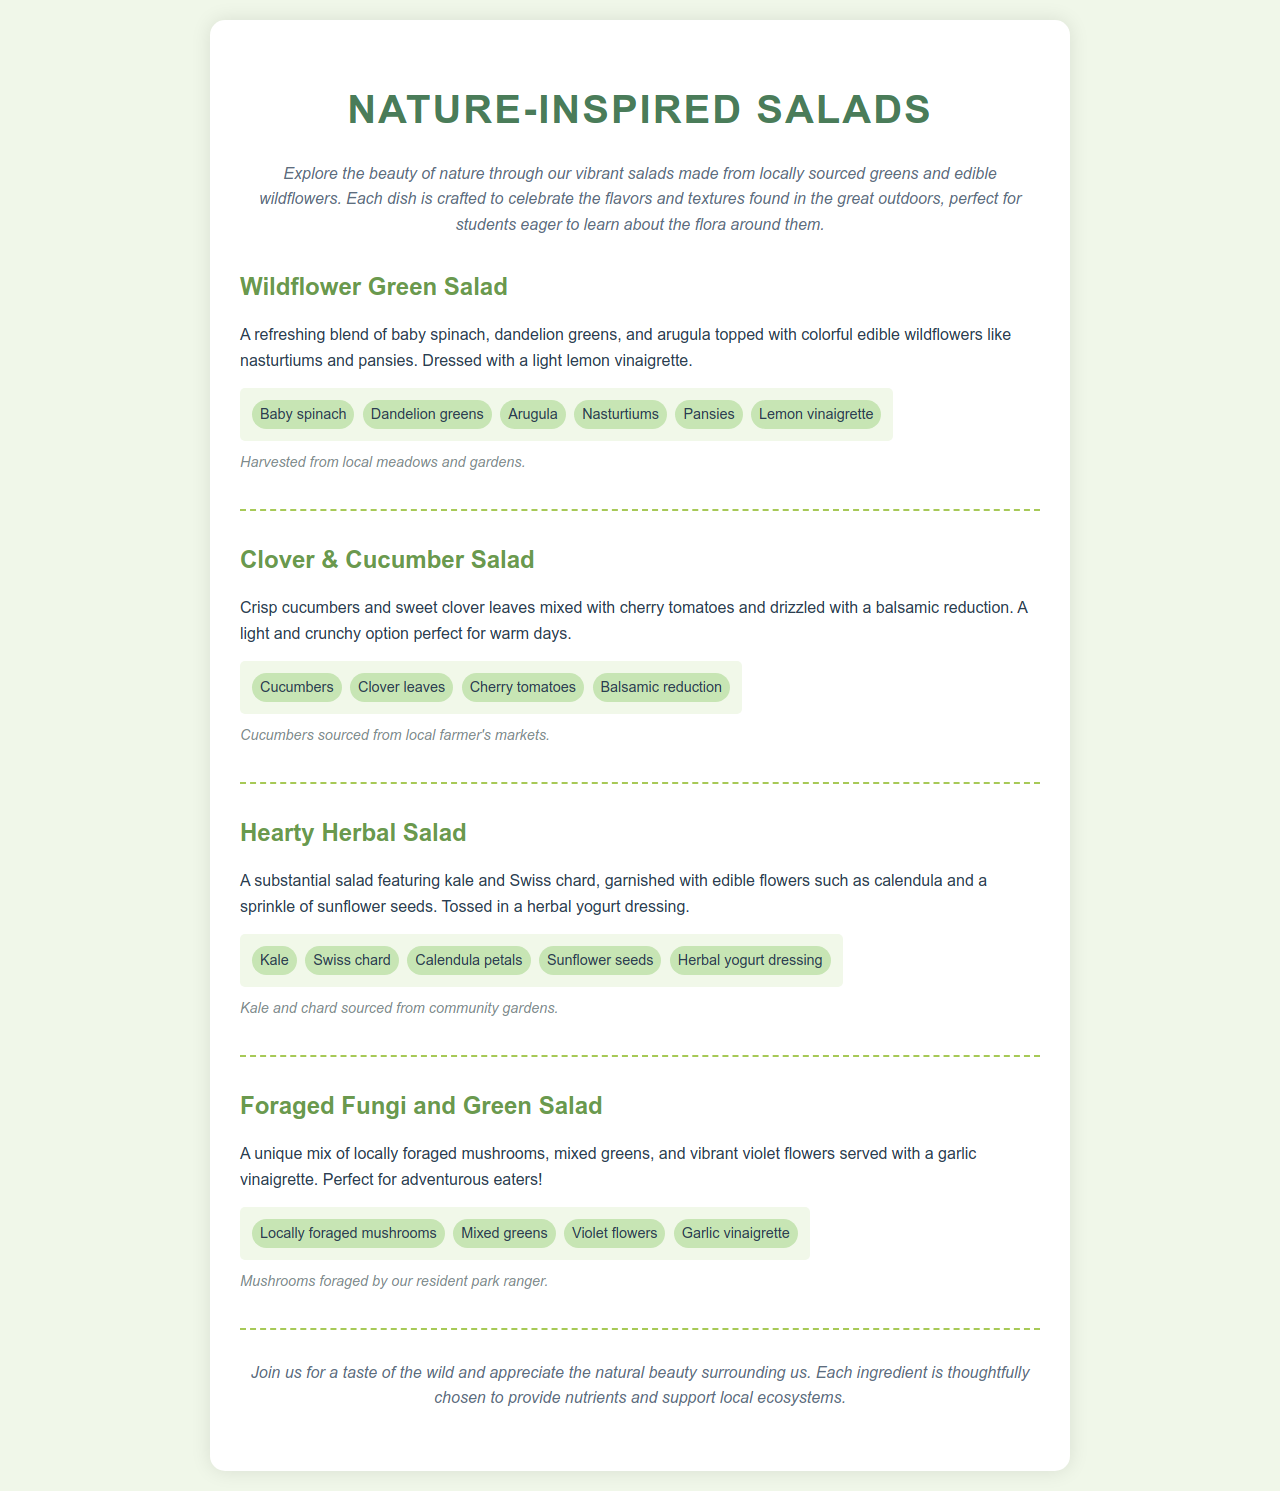What is the name of the first salad? The first salad is titled "Wildflower Green Salad."
Answer: Wildflower Green Salad What type of dressing is used in the Hearty Herbal Salad? The dressing used is a herbal yogurt dressing.
Answer: Herbal yogurt dressing Which wildflower is included in the Wildflower Green Salad? The Wildflower Green Salad includes nasturtiums and pansies.
Answer: Nasturtiums, pansies What is a unique ingredient in the Foraged Fungi and Green Salad? The Foraged Fungi and Green Salad features locally foraged mushrooms.
Answer: Locally foraged mushrooms Where are the cucumbers in the Clover & Cucumber Salad sourced from? The cucumbers are sourced from local farmer's markets.
Answer: Local farmer's markets What main greens are featured in the Hearty Herbal Salad? The main greens featured are kale and Swiss chard.
Answer: Kale, Swiss chard What is the description for the Clover & Cucumber Salad? The Clover & Cucumber Salad features crisp cucumbers and sweet clover leaves mixed with cherry tomatoes and drizzled with a balsamic reduction.
Answer: Crisp cucumbers, sweet clover leaves, cherry tomatoes, balsamic reduction How are the mushrooms in the Foraged Fungi and Green Salad acquired? The mushrooms are foraged by the resident park ranger.
Answer: Foraged by our resident park ranger 